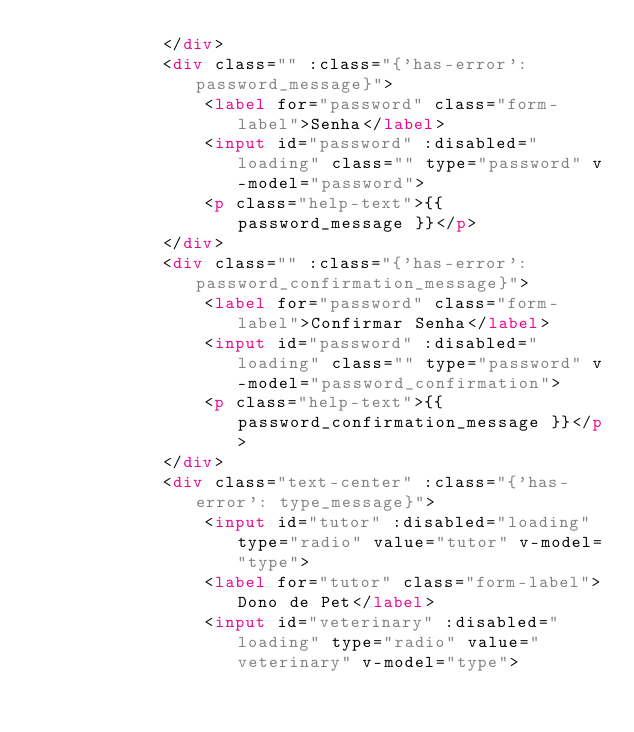Convert code to text. <code><loc_0><loc_0><loc_500><loc_500><_HTML_>            </div>
            <div class="" :class="{'has-error': password_message}">
                <label for="password" class="form-label">Senha</label>
                <input id="password" :disabled="loading" class="" type="password" v-model="password">
                <p class="help-text">{{ password_message }}</p>
            </div>
            <div class="" :class="{'has-error': password_confirmation_message}">
                <label for="password" class="form-label">Confirmar Senha</label>
                <input id="password" :disabled="loading" class="" type="password" v-model="password_confirmation">
                <p class="help-text">{{ password_confirmation_message }}</p>
            </div>
            <div class="text-center" :class="{'has-error': type_message}">
                <input id="tutor" :disabled="loading" type="radio" value="tutor" v-model="type">
                <label for="tutor" class="form-label">Dono de Pet</label>
                <input id="veterinary" :disabled="loading" type="radio" value="veterinary" v-model="type"></code> 